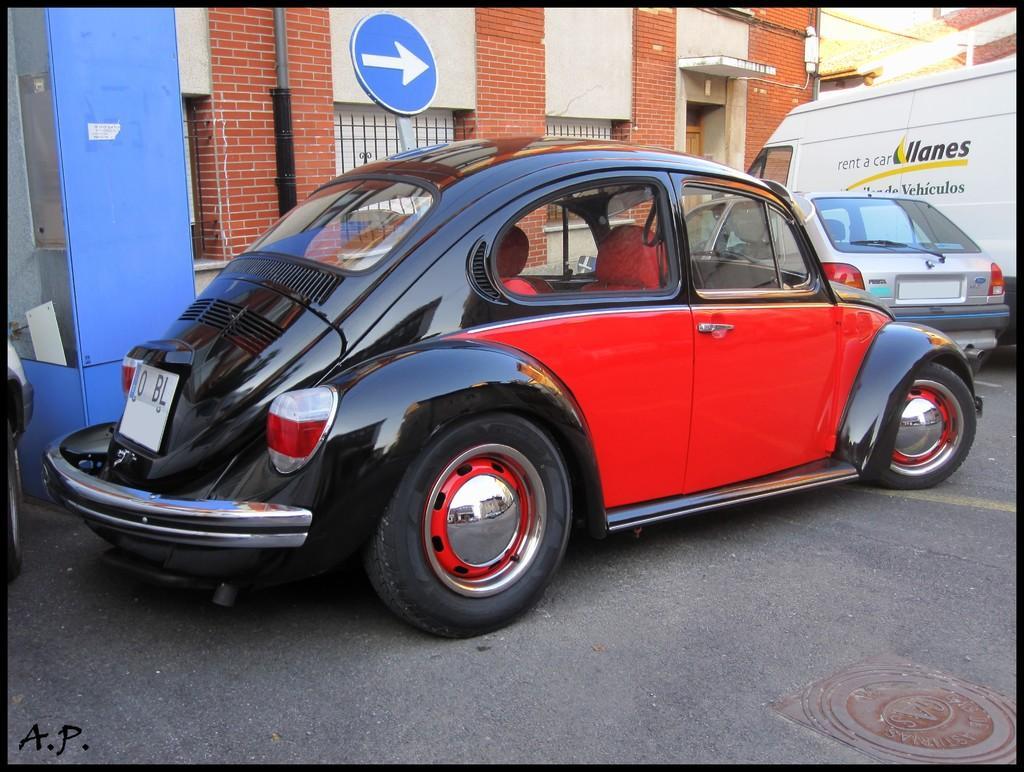Describe this image in one or two sentences. In this image, we can see vehicles on the road and in the background, we can see buildings, pole, a signboard and there is a booth. 